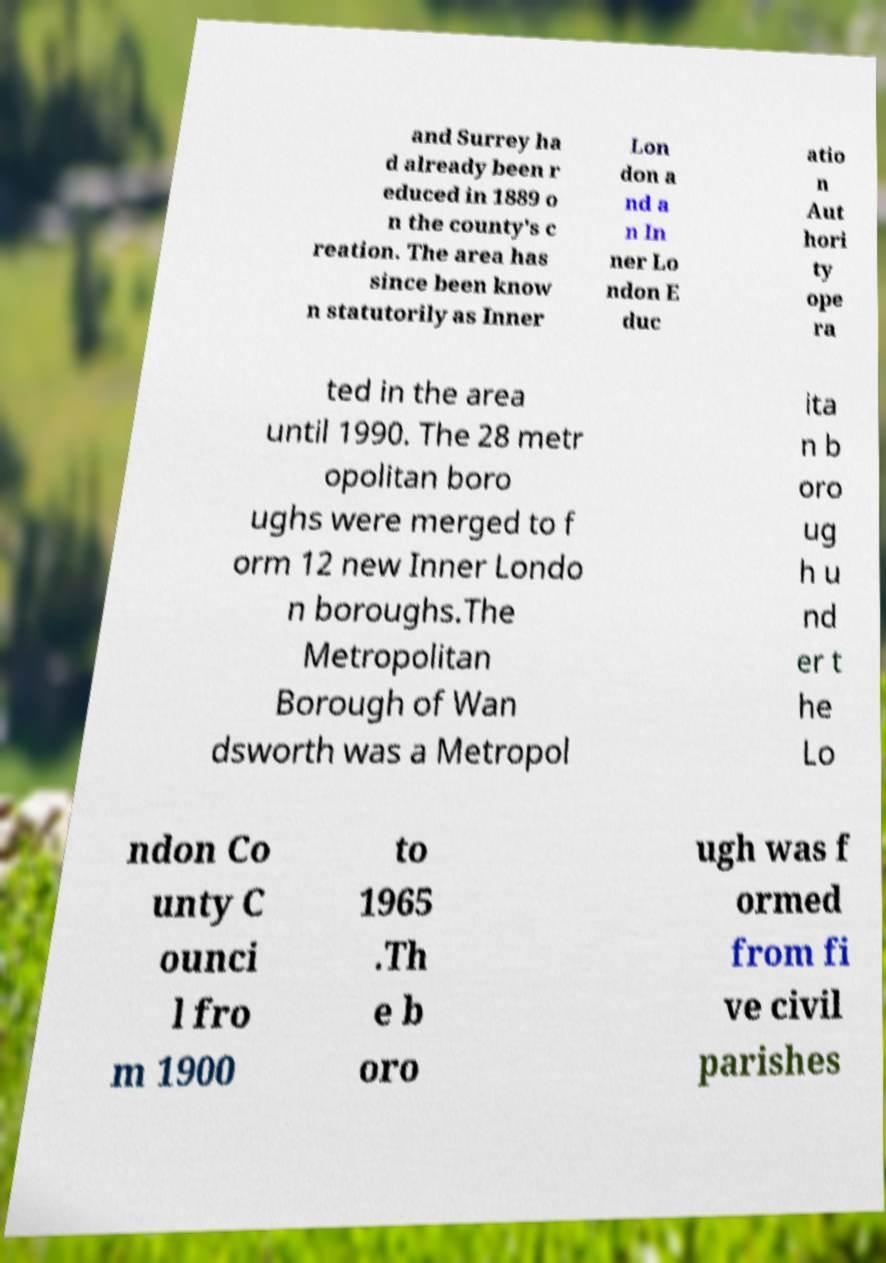Please read and relay the text visible in this image. What does it say? and Surrey ha d already been r educed in 1889 o n the county's c reation. The area has since been know n statutorily as Inner Lon don a nd a n In ner Lo ndon E duc atio n Aut hori ty ope ra ted in the area until 1990. The 28 metr opolitan boro ughs were merged to f orm 12 new Inner Londo n boroughs.The Metropolitan Borough of Wan dsworth was a Metropol ita n b oro ug h u nd er t he Lo ndon Co unty C ounci l fro m 1900 to 1965 .Th e b oro ugh was f ormed from fi ve civil parishes 